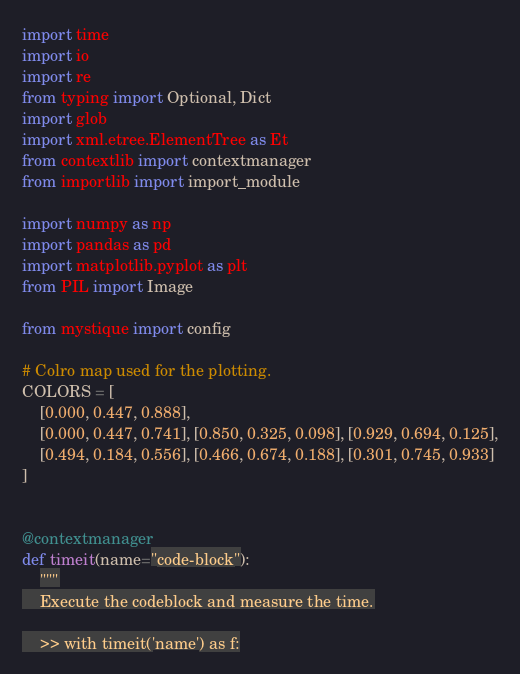<code> <loc_0><loc_0><loc_500><loc_500><_Python_>import time
import io
import re
from typing import Optional, Dict
import glob
import xml.etree.ElementTree as Et
from contextlib import contextmanager
from importlib import import_module

import numpy as np
import pandas as pd
import matplotlib.pyplot as plt
from PIL import Image

from mystique import config

# Colro map used for the plotting.
COLORS = [
    [0.000, 0.447, 0.888],
    [0.000, 0.447, 0.741], [0.850, 0.325, 0.098], [0.929, 0.694, 0.125],
    [0.494, 0.184, 0.556], [0.466, 0.674, 0.188], [0.301, 0.745, 0.933]
]


@contextmanager
def timeit(name="code-block"):
    """
    Execute the codeblock and measure the time.

    >> with timeit('name') as f:</code> 